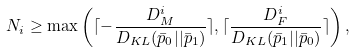<formula> <loc_0><loc_0><loc_500><loc_500>N _ { i } \geq \max \left ( \lceil - \frac { D _ { M } ^ { i } } { D _ { K L } ( \bar { p } _ { 0 } | | \bar { p } _ { 1 } ) } \rceil , \lceil \frac { D _ { F } ^ { i } } { D _ { K L } ( \bar { p } _ { 1 } | | \bar { p } _ { 0 } ) } \rceil \right ) ,</formula> 